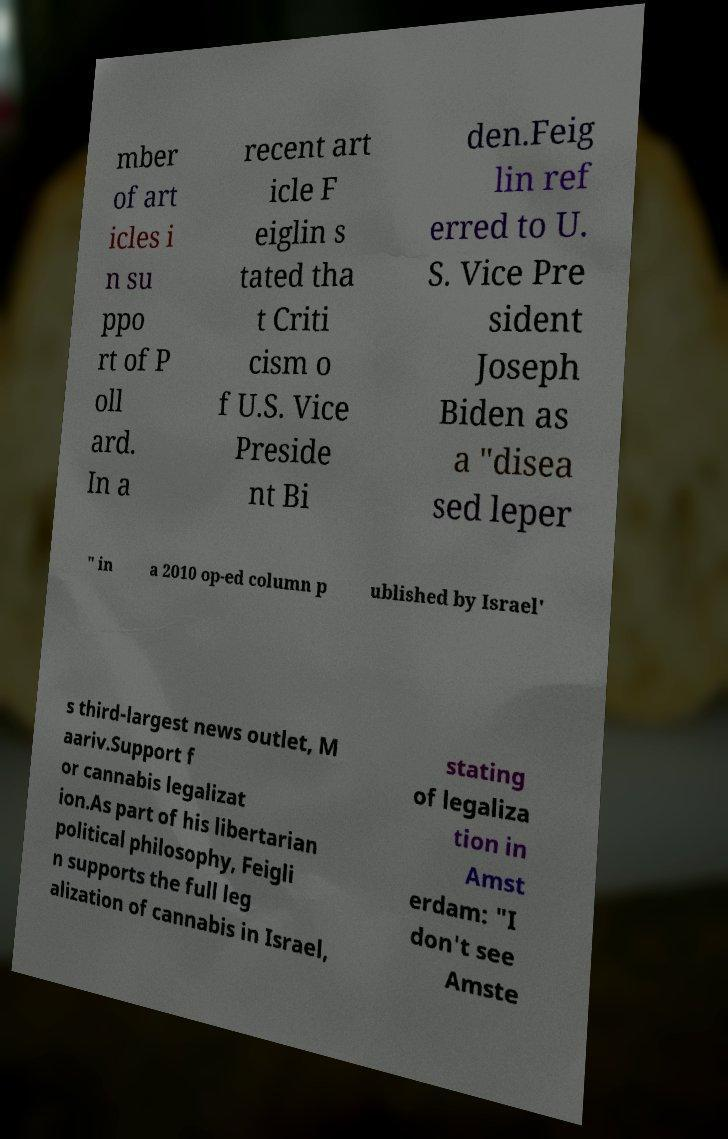What messages or text are displayed in this image? I need them in a readable, typed format. mber of art icles i n su ppo rt of P oll ard. In a recent art icle F eiglin s tated tha t Criti cism o f U.S. Vice Preside nt Bi den.Feig lin ref erred to U. S. Vice Pre sident Joseph Biden as a "disea sed leper " in a 2010 op-ed column p ublished by Israel' s third-largest news outlet, M aariv.Support f or cannabis legalizat ion.As part of his libertarian political philosophy, Feigli n supports the full leg alization of cannabis in Israel, stating of legaliza tion in Amst erdam: "I don't see Amste 